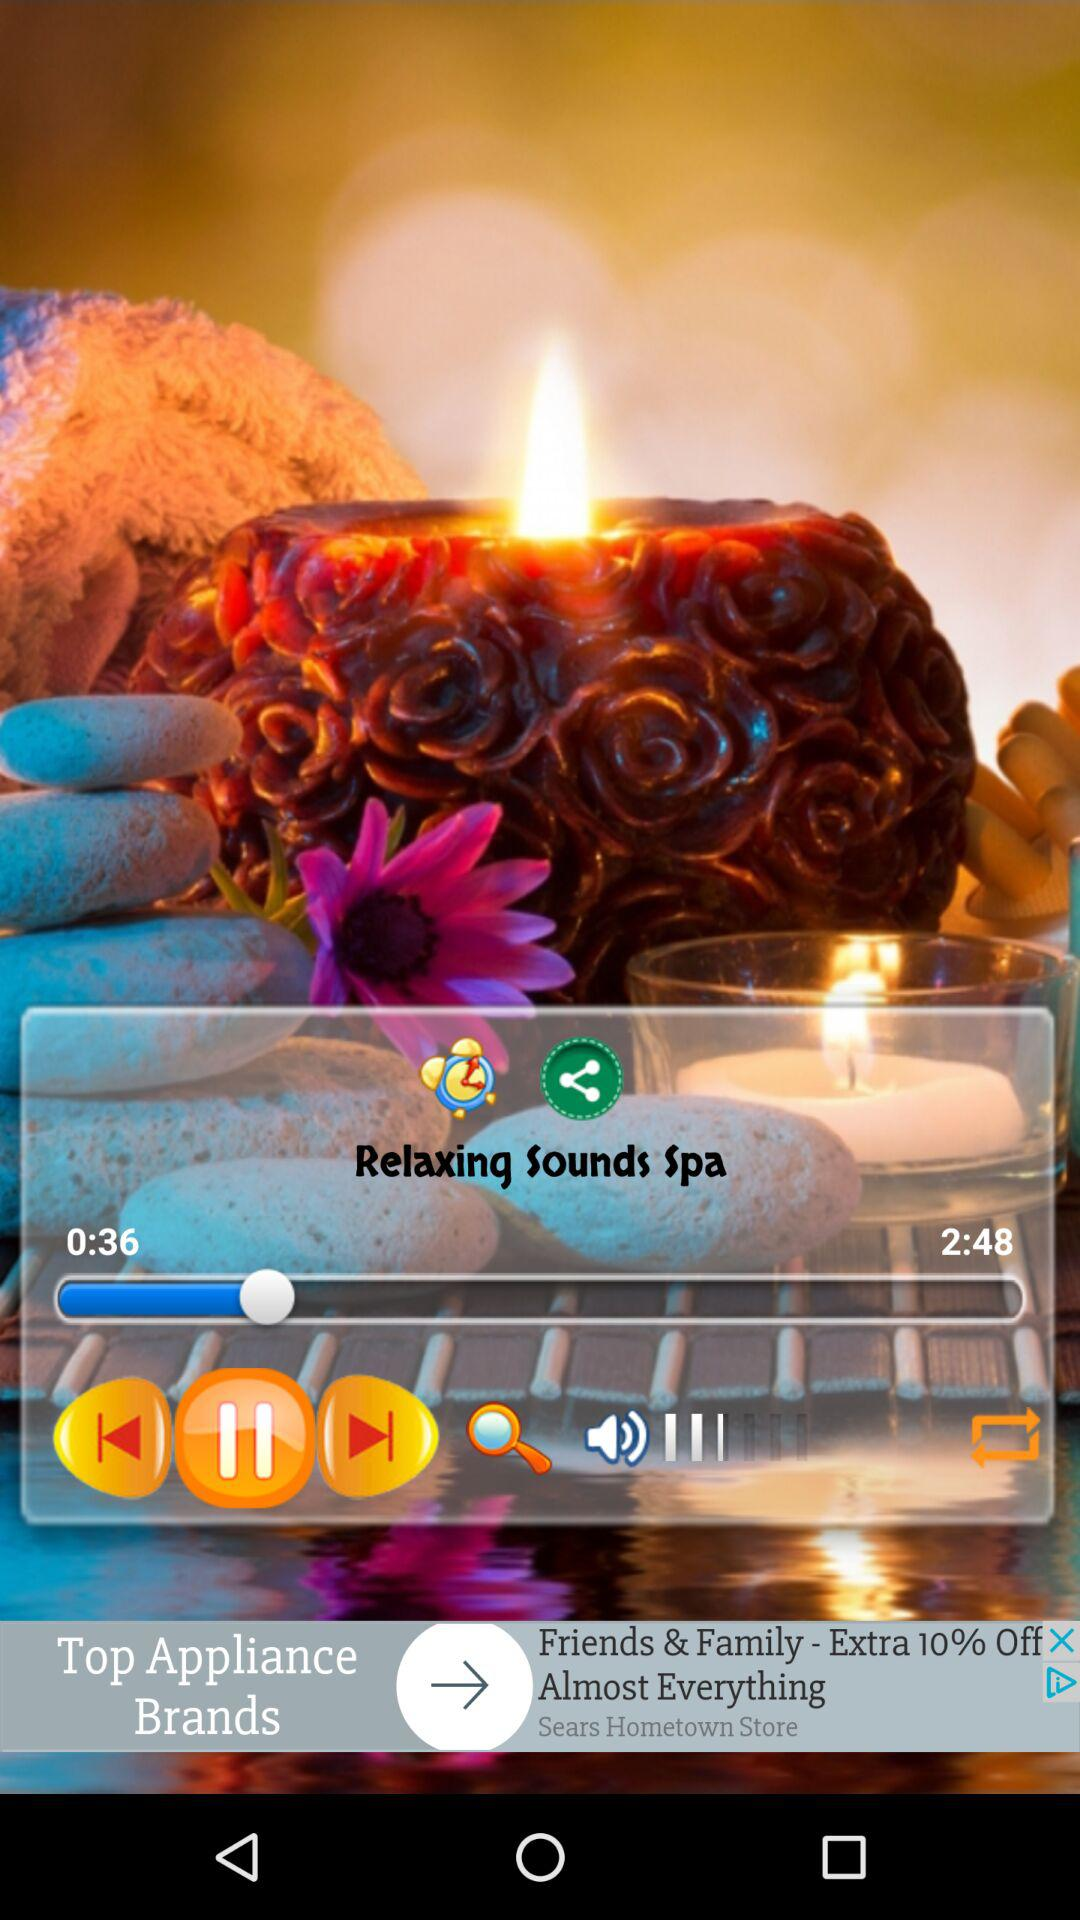What duration of audio is being played? The duration of the audio being played is 2:48. 